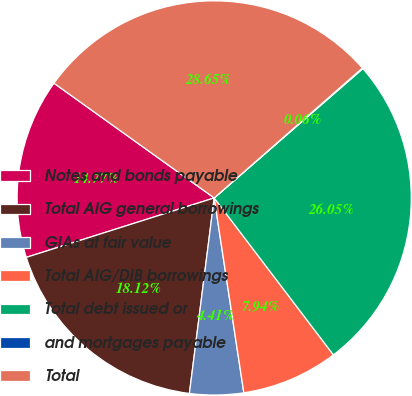Convert chart. <chart><loc_0><loc_0><loc_500><loc_500><pie_chart><fcel>Notes and bonds payable<fcel>Total AIG general borrowings<fcel>GIAs at fair value<fcel>Total AIG/DIB borrowings<fcel>Total debt issued or<fcel>and mortgages payable<fcel>Total<nl><fcel>14.77%<fcel>18.12%<fcel>4.41%<fcel>7.94%<fcel>26.06%<fcel>0.06%<fcel>28.66%<nl></chart> 